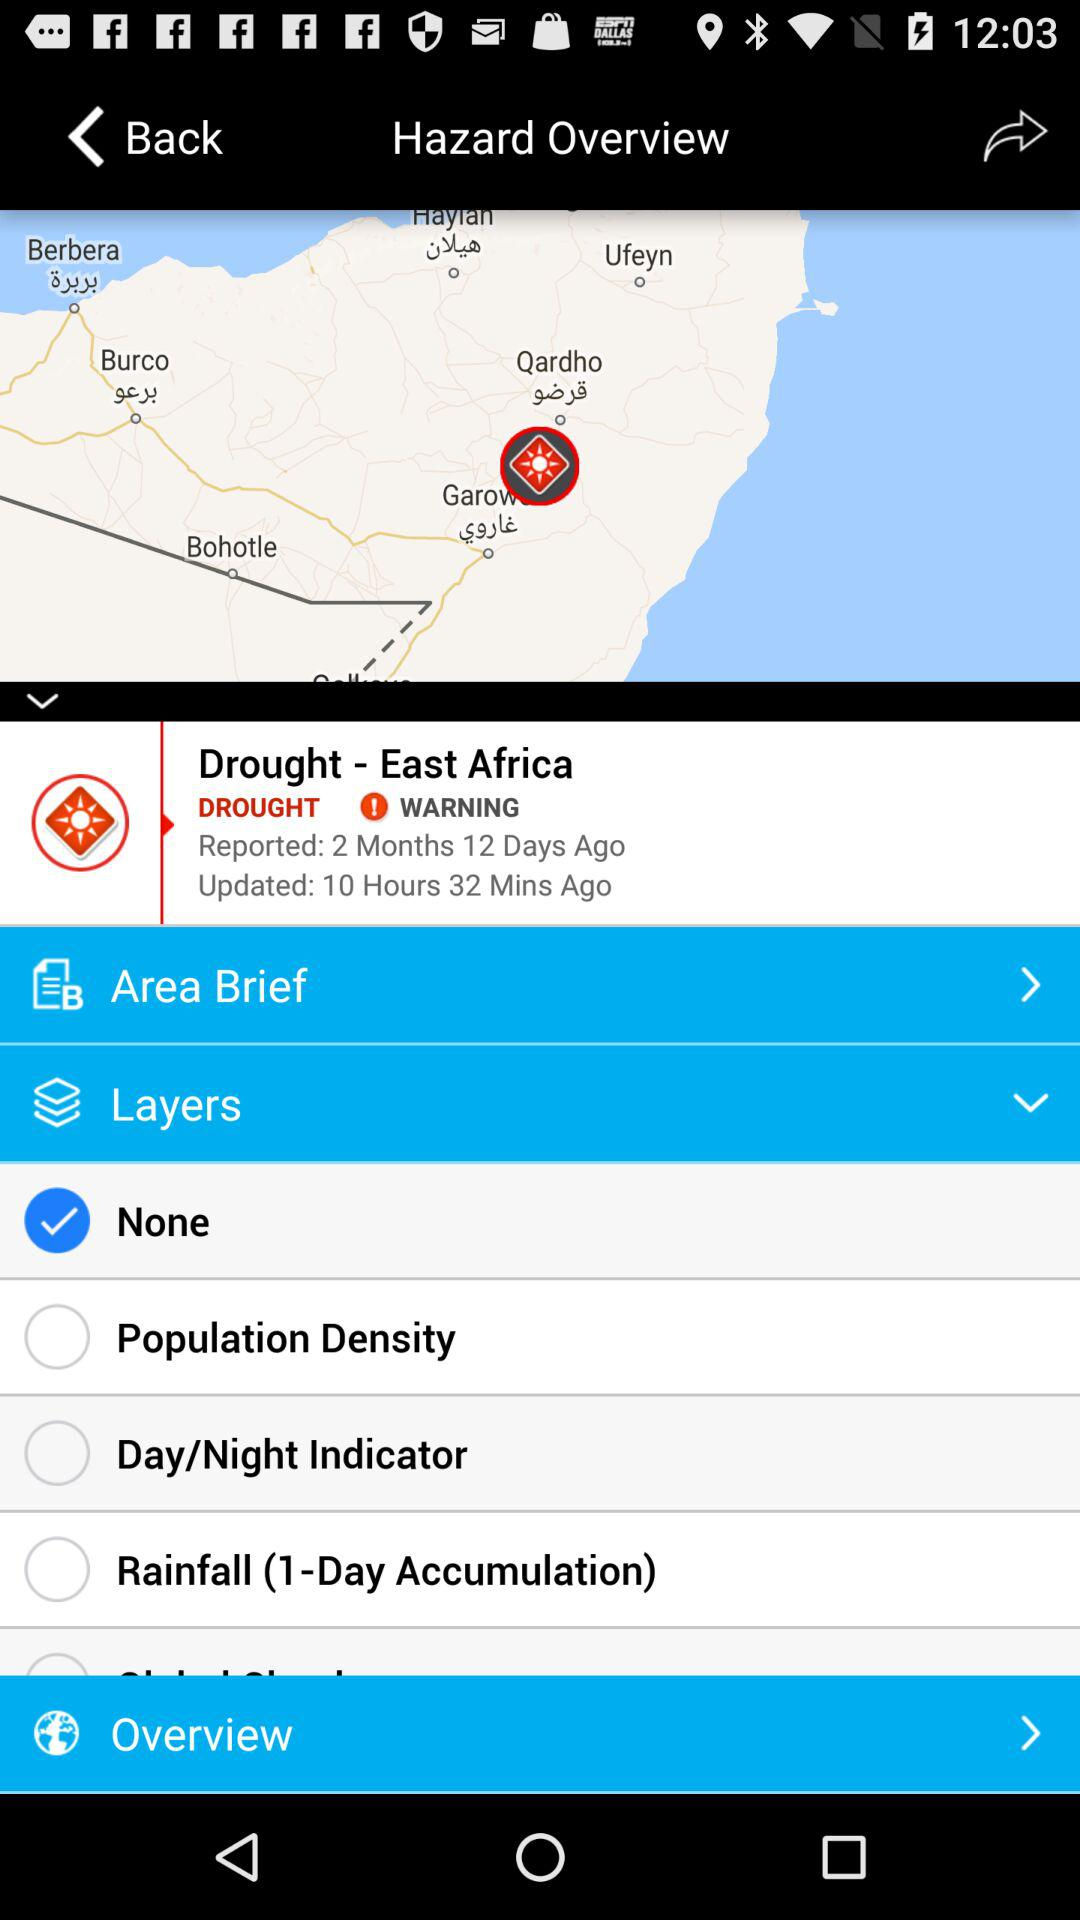What option has been chosen in the layers? The option that has been selected is "None". 